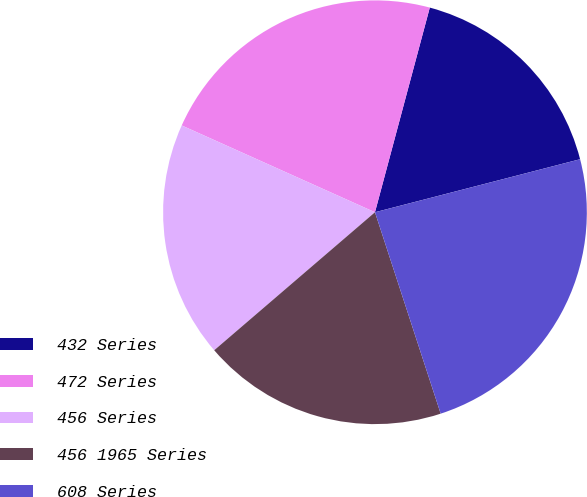Convert chart to OTSL. <chart><loc_0><loc_0><loc_500><loc_500><pie_chart><fcel>432 Series<fcel>472 Series<fcel>456 Series<fcel>456 1965 Series<fcel>608 Series<nl><fcel>16.81%<fcel>22.45%<fcel>18.01%<fcel>18.73%<fcel>24.01%<nl></chart> 